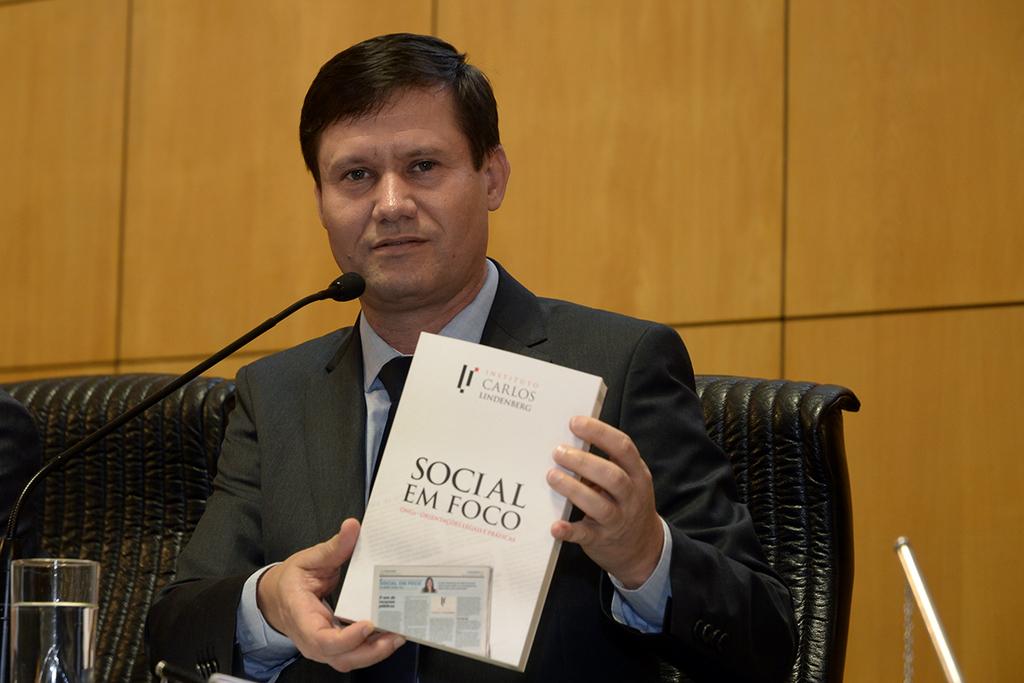Who authored the book?
Ensure brevity in your answer.  Carlos lindenburg. 